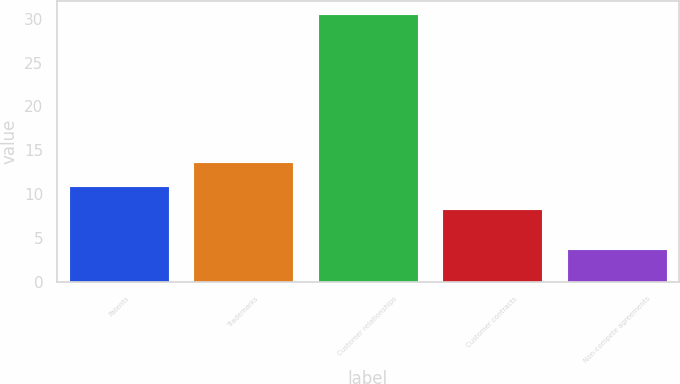Convert chart to OTSL. <chart><loc_0><loc_0><loc_500><loc_500><bar_chart><fcel>Patents<fcel>Trademarks<fcel>Customer relationships<fcel>Customer contracts<fcel>Non-compete agreements<nl><fcel>10.97<fcel>13.64<fcel>30.5<fcel>8.3<fcel>3.8<nl></chart> 